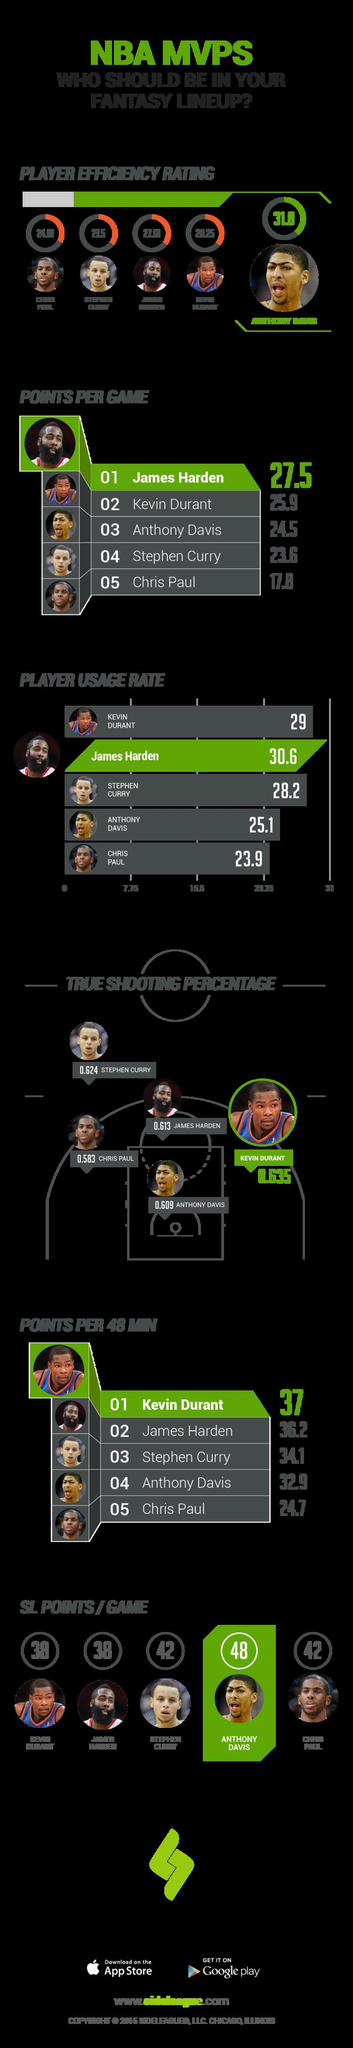Identify some key points in this picture. Of the five NBA players shown, Stephen Curry has the second-lowest Points per Game. Anthony Davis, the NBA player featured in the infographic, has a SL Points/Game average above 45. The infographic displays a NBA player with the second highest True shooting percentage, which is Stephen Curry. The NBA player shown in the infographic with the third highest True shooting percentage is James Harden. Chris Paul, the player featured in the infographic, has a Points Per Game score below 20. 